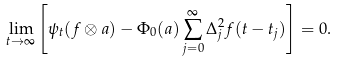Convert formula to latex. <formula><loc_0><loc_0><loc_500><loc_500>\lim _ { t \to \infty } \left [ \psi _ { t } ( f \otimes a ) - \Phi _ { 0 } ( a ) \sum _ { j = 0 } ^ { \infty } \Delta _ { j } ^ { 2 } f ( t - t _ { j } ) \right ] = 0 .</formula> 